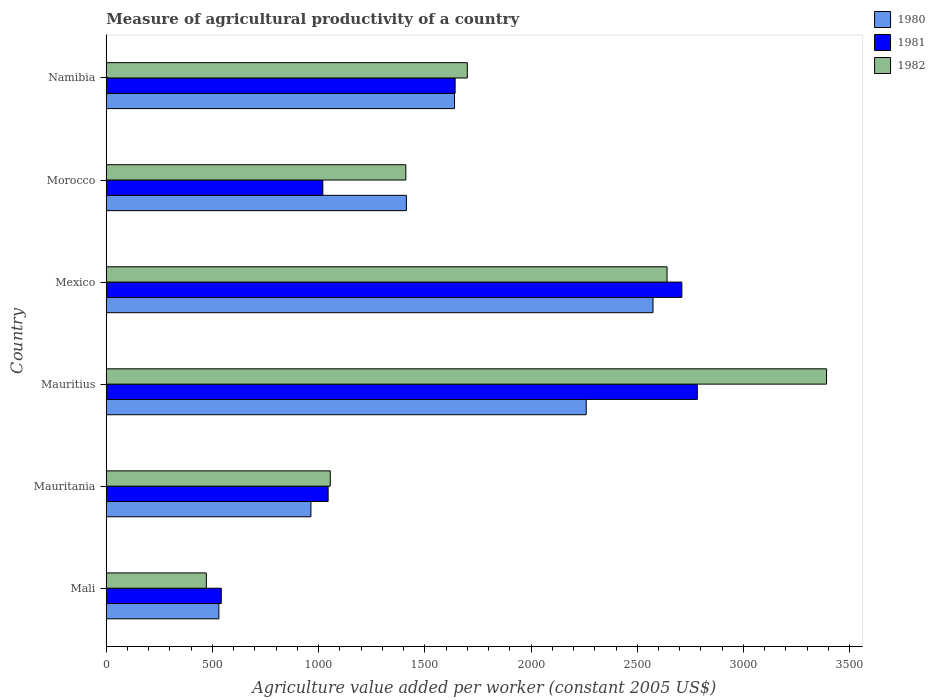How many groups of bars are there?
Keep it short and to the point. 6. What is the label of the 4th group of bars from the top?
Your answer should be very brief. Mauritius. What is the measure of agricultural productivity in 1981 in Morocco?
Keep it short and to the point. 1019.64. Across all countries, what is the maximum measure of agricultural productivity in 1981?
Keep it short and to the point. 2783.08. Across all countries, what is the minimum measure of agricultural productivity in 1981?
Your response must be concise. 541.6. In which country was the measure of agricultural productivity in 1982 maximum?
Your answer should be compact. Mauritius. In which country was the measure of agricultural productivity in 1980 minimum?
Provide a succinct answer. Mali. What is the total measure of agricultural productivity in 1981 in the graph?
Make the answer very short. 9741.52. What is the difference between the measure of agricultural productivity in 1982 in Mali and that in Mexico?
Your response must be concise. -2168.99. What is the difference between the measure of agricultural productivity in 1980 in Namibia and the measure of agricultural productivity in 1982 in Mexico?
Provide a succinct answer. -1000.57. What is the average measure of agricultural productivity in 1981 per country?
Your answer should be very brief. 1623.59. What is the difference between the measure of agricultural productivity in 1981 and measure of agricultural productivity in 1980 in Morocco?
Give a very brief answer. -393.45. What is the ratio of the measure of agricultural productivity in 1980 in Mauritius to that in Morocco?
Offer a very short reply. 1.6. What is the difference between the highest and the second highest measure of agricultural productivity in 1980?
Your answer should be compact. 314.51. What is the difference between the highest and the lowest measure of agricultural productivity in 1982?
Provide a succinct answer. 2919.89. In how many countries, is the measure of agricultural productivity in 1982 greater than the average measure of agricultural productivity in 1982 taken over all countries?
Make the answer very short. 2. Is it the case that in every country, the sum of the measure of agricultural productivity in 1982 and measure of agricultural productivity in 1980 is greater than the measure of agricultural productivity in 1981?
Provide a short and direct response. Yes. How many bars are there?
Ensure brevity in your answer.  18. How many countries are there in the graph?
Your answer should be compact. 6. What is the difference between two consecutive major ticks on the X-axis?
Offer a terse response. 500. Are the values on the major ticks of X-axis written in scientific E-notation?
Ensure brevity in your answer.  No. Does the graph contain any zero values?
Provide a short and direct response. No. Does the graph contain grids?
Offer a terse response. No. How are the legend labels stacked?
Ensure brevity in your answer.  Vertical. What is the title of the graph?
Your response must be concise. Measure of agricultural productivity of a country. Does "2008" appear as one of the legend labels in the graph?
Keep it short and to the point. No. What is the label or title of the X-axis?
Ensure brevity in your answer.  Agriculture value added per worker (constant 2005 US$). What is the label or title of the Y-axis?
Offer a very short reply. Country. What is the Agriculture value added per worker (constant 2005 US$) in 1980 in Mali?
Give a very brief answer. 530.29. What is the Agriculture value added per worker (constant 2005 US$) of 1981 in Mali?
Your response must be concise. 541.6. What is the Agriculture value added per worker (constant 2005 US$) in 1982 in Mali?
Offer a terse response. 471.28. What is the Agriculture value added per worker (constant 2005 US$) in 1980 in Mauritania?
Your answer should be very brief. 963.64. What is the Agriculture value added per worker (constant 2005 US$) in 1981 in Mauritania?
Offer a very short reply. 1044.71. What is the Agriculture value added per worker (constant 2005 US$) in 1982 in Mauritania?
Make the answer very short. 1054.73. What is the Agriculture value added per worker (constant 2005 US$) of 1980 in Mauritius?
Offer a terse response. 2259.73. What is the Agriculture value added per worker (constant 2005 US$) in 1981 in Mauritius?
Provide a short and direct response. 2783.08. What is the Agriculture value added per worker (constant 2005 US$) in 1982 in Mauritius?
Your answer should be very brief. 3391.17. What is the Agriculture value added per worker (constant 2005 US$) in 1980 in Mexico?
Your answer should be compact. 2574.24. What is the Agriculture value added per worker (constant 2005 US$) in 1981 in Mexico?
Provide a short and direct response. 2709.94. What is the Agriculture value added per worker (constant 2005 US$) in 1982 in Mexico?
Ensure brevity in your answer.  2640.27. What is the Agriculture value added per worker (constant 2005 US$) in 1980 in Morocco?
Provide a short and direct response. 1413.09. What is the Agriculture value added per worker (constant 2005 US$) of 1981 in Morocco?
Offer a very short reply. 1019.64. What is the Agriculture value added per worker (constant 2005 US$) in 1982 in Morocco?
Keep it short and to the point. 1410.49. What is the Agriculture value added per worker (constant 2005 US$) in 1980 in Namibia?
Provide a succinct answer. 1639.69. What is the Agriculture value added per worker (constant 2005 US$) in 1981 in Namibia?
Your answer should be compact. 1642.55. What is the Agriculture value added per worker (constant 2005 US$) in 1982 in Namibia?
Make the answer very short. 1699.99. Across all countries, what is the maximum Agriculture value added per worker (constant 2005 US$) of 1980?
Your response must be concise. 2574.24. Across all countries, what is the maximum Agriculture value added per worker (constant 2005 US$) of 1981?
Your answer should be very brief. 2783.08. Across all countries, what is the maximum Agriculture value added per worker (constant 2005 US$) of 1982?
Keep it short and to the point. 3391.17. Across all countries, what is the minimum Agriculture value added per worker (constant 2005 US$) in 1980?
Provide a short and direct response. 530.29. Across all countries, what is the minimum Agriculture value added per worker (constant 2005 US$) in 1981?
Keep it short and to the point. 541.6. Across all countries, what is the minimum Agriculture value added per worker (constant 2005 US$) in 1982?
Give a very brief answer. 471.28. What is the total Agriculture value added per worker (constant 2005 US$) in 1980 in the graph?
Provide a succinct answer. 9380.68. What is the total Agriculture value added per worker (constant 2005 US$) of 1981 in the graph?
Give a very brief answer. 9741.52. What is the total Agriculture value added per worker (constant 2005 US$) of 1982 in the graph?
Give a very brief answer. 1.07e+04. What is the difference between the Agriculture value added per worker (constant 2005 US$) of 1980 in Mali and that in Mauritania?
Your answer should be compact. -433.35. What is the difference between the Agriculture value added per worker (constant 2005 US$) in 1981 in Mali and that in Mauritania?
Your answer should be compact. -503.1. What is the difference between the Agriculture value added per worker (constant 2005 US$) in 1982 in Mali and that in Mauritania?
Offer a terse response. -583.45. What is the difference between the Agriculture value added per worker (constant 2005 US$) in 1980 in Mali and that in Mauritius?
Keep it short and to the point. -1729.44. What is the difference between the Agriculture value added per worker (constant 2005 US$) of 1981 in Mali and that in Mauritius?
Provide a short and direct response. -2241.48. What is the difference between the Agriculture value added per worker (constant 2005 US$) in 1982 in Mali and that in Mauritius?
Make the answer very short. -2919.89. What is the difference between the Agriculture value added per worker (constant 2005 US$) of 1980 in Mali and that in Mexico?
Provide a succinct answer. -2043.95. What is the difference between the Agriculture value added per worker (constant 2005 US$) in 1981 in Mali and that in Mexico?
Offer a terse response. -2168.34. What is the difference between the Agriculture value added per worker (constant 2005 US$) in 1982 in Mali and that in Mexico?
Keep it short and to the point. -2168.99. What is the difference between the Agriculture value added per worker (constant 2005 US$) in 1980 in Mali and that in Morocco?
Ensure brevity in your answer.  -882.8. What is the difference between the Agriculture value added per worker (constant 2005 US$) in 1981 in Mali and that in Morocco?
Make the answer very short. -478.04. What is the difference between the Agriculture value added per worker (constant 2005 US$) of 1982 in Mali and that in Morocco?
Provide a succinct answer. -939.21. What is the difference between the Agriculture value added per worker (constant 2005 US$) in 1980 in Mali and that in Namibia?
Your response must be concise. -1109.4. What is the difference between the Agriculture value added per worker (constant 2005 US$) in 1981 in Mali and that in Namibia?
Provide a succinct answer. -1100.95. What is the difference between the Agriculture value added per worker (constant 2005 US$) of 1982 in Mali and that in Namibia?
Ensure brevity in your answer.  -1228.71. What is the difference between the Agriculture value added per worker (constant 2005 US$) of 1980 in Mauritania and that in Mauritius?
Make the answer very short. -1296.09. What is the difference between the Agriculture value added per worker (constant 2005 US$) of 1981 in Mauritania and that in Mauritius?
Your answer should be very brief. -1738.38. What is the difference between the Agriculture value added per worker (constant 2005 US$) of 1982 in Mauritania and that in Mauritius?
Your answer should be compact. -2336.44. What is the difference between the Agriculture value added per worker (constant 2005 US$) in 1980 in Mauritania and that in Mexico?
Give a very brief answer. -1610.59. What is the difference between the Agriculture value added per worker (constant 2005 US$) in 1981 in Mauritania and that in Mexico?
Provide a short and direct response. -1665.24. What is the difference between the Agriculture value added per worker (constant 2005 US$) of 1982 in Mauritania and that in Mexico?
Provide a short and direct response. -1585.54. What is the difference between the Agriculture value added per worker (constant 2005 US$) in 1980 in Mauritania and that in Morocco?
Provide a succinct answer. -449.45. What is the difference between the Agriculture value added per worker (constant 2005 US$) in 1981 in Mauritania and that in Morocco?
Your answer should be very brief. 25.06. What is the difference between the Agriculture value added per worker (constant 2005 US$) of 1982 in Mauritania and that in Morocco?
Keep it short and to the point. -355.76. What is the difference between the Agriculture value added per worker (constant 2005 US$) in 1980 in Mauritania and that in Namibia?
Your answer should be very brief. -676.05. What is the difference between the Agriculture value added per worker (constant 2005 US$) of 1981 in Mauritania and that in Namibia?
Make the answer very short. -597.85. What is the difference between the Agriculture value added per worker (constant 2005 US$) of 1982 in Mauritania and that in Namibia?
Keep it short and to the point. -645.26. What is the difference between the Agriculture value added per worker (constant 2005 US$) of 1980 in Mauritius and that in Mexico?
Provide a succinct answer. -314.51. What is the difference between the Agriculture value added per worker (constant 2005 US$) in 1981 in Mauritius and that in Mexico?
Offer a terse response. 73.14. What is the difference between the Agriculture value added per worker (constant 2005 US$) of 1982 in Mauritius and that in Mexico?
Offer a terse response. 750.9. What is the difference between the Agriculture value added per worker (constant 2005 US$) of 1980 in Mauritius and that in Morocco?
Your answer should be compact. 846.64. What is the difference between the Agriculture value added per worker (constant 2005 US$) in 1981 in Mauritius and that in Morocco?
Make the answer very short. 1763.44. What is the difference between the Agriculture value added per worker (constant 2005 US$) of 1982 in Mauritius and that in Morocco?
Offer a very short reply. 1980.68. What is the difference between the Agriculture value added per worker (constant 2005 US$) of 1980 in Mauritius and that in Namibia?
Ensure brevity in your answer.  620.04. What is the difference between the Agriculture value added per worker (constant 2005 US$) in 1981 in Mauritius and that in Namibia?
Ensure brevity in your answer.  1140.53. What is the difference between the Agriculture value added per worker (constant 2005 US$) in 1982 in Mauritius and that in Namibia?
Provide a short and direct response. 1691.18. What is the difference between the Agriculture value added per worker (constant 2005 US$) in 1980 in Mexico and that in Morocco?
Your answer should be very brief. 1161.14. What is the difference between the Agriculture value added per worker (constant 2005 US$) in 1981 in Mexico and that in Morocco?
Your answer should be compact. 1690.3. What is the difference between the Agriculture value added per worker (constant 2005 US$) of 1982 in Mexico and that in Morocco?
Ensure brevity in your answer.  1229.78. What is the difference between the Agriculture value added per worker (constant 2005 US$) of 1980 in Mexico and that in Namibia?
Provide a succinct answer. 934.54. What is the difference between the Agriculture value added per worker (constant 2005 US$) in 1981 in Mexico and that in Namibia?
Your answer should be compact. 1067.39. What is the difference between the Agriculture value added per worker (constant 2005 US$) in 1982 in Mexico and that in Namibia?
Offer a terse response. 940.28. What is the difference between the Agriculture value added per worker (constant 2005 US$) of 1980 in Morocco and that in Namibia?
Your response must be concise. -226.6. What is the difference between the Agriculture value added per worker (constant 2005 US$) of 1981 in Morocco and that in Namibia?
Ensure brevity in your answer.  -622.91. What is the difference between the Agriculture value added per worker (constant 2005 US$) in 1982 in Morocco and that in Namibia?
Provide a succinct answer. -289.5. What is the difference between the Agriculture value added per worker (constant 2005 US$) of 1980 in Mali and the Agriculture value added per worker (constant 2005 US$) of 1981 in Mauritania?
Offer a terse response. -514.42. What is the difference between the Agriculture value added per worker (constant 2005 US$) of 1980 in Mali and the Agriculture value added per worker (constant 2005 US$) of 1982 in Mauritania?
Provide a succinct answer. -524.44. What is the difference between the Agriculture value added per worker (constant 2005 US$) in 1981 in Mali and the Agriculture value added per worker (constant 2005 US$) in 1982 in Mauritania?
Your answer should be compact. -513.12. What is the difference between the Agriculture value added per worker (constant 2005 US$) in 1980 in Mali and the Agriculture value added per worker (constant 2005 US$) in 1981 in Mauritius?
Offer a very short reply. -2252.79. What is the difference between the Agriculture value added per worker (constant 2005 US$) of 1980 in Mali and the Agriculture value added per worker (constant 2005 US$) of 1982 in Mauritius?
Your answer should be compact. -2860.88. What is the difference between the Agriculture value added per worker (constant 2005 US$) in 1981 in Mali and the Agriculture value added per worker (constant 2005 US$) in 1982 in Mauritius?
Offer a terse response. -2849.57. What is the difference between the Agriculture value added per worker (constant 2005 US$) of 1980 in Mali and the Agriculture value added per worker (constant 2005 US$) of 1981 in Mexico?
Your answer should be very brief. -2179.65. What is the difference between the Agriculture value added per worker (constant 2005 US$) in 1980 in Mali and the Agriculture value added per worker (constant 2005 US$) in 1982 in Mexico?
Provide a succinct answer. -2109.98. What is the difference between the Agriculture value added per worker (constant 2005 US$) in 1981 in Mali and the Agriculture value added per worker (constant 2005 US$) in 1982 in Mexico?
Provide a succinct answer. -2098.66. What is the difference between the Agriculture value added per worker (constant 2005 US$) in 1980 in Mali and the Agriculture value added per worker (constant 2005 US$) in 1981 in Morocco?
Provide a short and direct response. -489.35. What is the difference between the Agriculture value added per worker (constant 2005 US$) in 1980 in Mali and the Agriculture value added per worker (constant 2005 US$) in 1982 in Morocco?
Provide a short and direct response. -880.2. What is the difference between the Agriculture value added per worker (constant 2005 US$) of 1981 in Mali and the Agriculture value added per worker (constant 2005 US$) of 1982 in Morocco?
Offer a terse response. -868.89. What is the difference between the Agriculture value added per worker (constant 2005 US$) of 1980 in Mali and the Agriculture value added per worker (constant 2005 US$) of 1981 in Namibia?
Your answer should be compact. -1112.26. What is the difference between the Agriculture value added per worker (constant 2005 US$) of 1980 in Mali and the Agriculture value added per worker (constant 2005 US$) of 1982 in Namibia?
Ensure brevity in your answer.  -1169.7. What is the difference between the Agriculture value added per worker (constant 2005 US$) of 1981 in Mali and the Agriculture value added per worker (constant 2005 US$) of 1982 in Namibia?
Provide a short and direct response. -1158.38. What is the difference between the Agriculture value added per worker (constant 2005 US$) of 1980 in Mauritania and the Agriculture value added per worker (constant 2005 US$) of 1981 in Mauritius?
Your answer should be compact. -1819.44. What is the difference between the Agriculture value added per worker (constant 2005 US$) of 1980 in Mauritania and the Agriculture value added per worker (constant 2005 US$) of 1982 in Mauritius?
Your answer should be very brief. -2427.53. What is the difference between the Agriculture value added per worker (constant 2005 US$) of 1981 in Mauritania and the Agriculture value added per worker (constant 2005 US$) of 1982 in Mauritius?
Keep it short and to the point. -2346.46. What is the difference between the Agriculture value added per worker (constant 2005 US$) of 1980 in Mauritania and the Agriculture value added per worker (constant 2005 US$) of 1981 in Mexico?
Provide a succinct answer. -1746.3. What is the difference between the Agriculture value added per worker (constant 2005 US$) of 1980 in Mauritania and the Agriculture value added per worker (constant 2005 US$) of 1982 in Mexico?
Keep it short and to the point. -1676.62. What is the difference between the Agriculture value added per worker (constant 2005 US$) of 1981 in Mauritania and the Agriculture value added per worker (constant 2005 US$) of 1982 in Mexico?
Offer a very short reply. -1595.56. What is the difference between the Agriculture value added per worker (constant 2005 US$) in 1980 in Mauritania and the Agriculture value added per worker (constant 2005 US$) in 1981 in Morocco?
Your answer should be very brief. -56. What is the difference between the Agriculture value added per worker (constant 2005 US$) in 1980 in Mauritania and the Agriculture value added per worker (constant 2005 US$) in 1982 in Morocco?
Offer a very short reply. -446.85. What is the difference between the Agriculture value added per worker (constant 2005 US$) of 1981 in Mauritania and the Agriculture value added per worker (constant 2005 US$) of 1982 in Morocco?
Your response must be concise. -365.78. What is the difference between the Agriculture value added per worker (constant 2005 US$) in 1980 in Mauritania and the Agriculture value added per worker (constant 2005 US$) in 1981 in Namibia?
Offer a terse response. -678.91. What is the difference between the Agriculture value added per worker (constant 2005 US$) in 1980 in Mauritania and the Agriculture value added per worker (constant 2005 US$) in 1982 in Namibia?
Offer a terse response. -736.35. What is the difference between the Agriculture value added per worker (constant 2005 US$) of 1981 in Mauritania and the Agriculture value added per worker (constant 2005 US$) of 1982 in Namibia?
Your response must be concise. -655.28. What is the difference between the Agriculture value added per worker (constant 2005 US$) in 1980 in Mauritius and the Agriculture value added per worker (constant 2005 US$) in 1981 in Mexico?
Keep it short and to the point. -450.21. What is the difference between the Agriculture value added per worker (constant 2005 US$) in 1980 in Mauritius and the Agriculture value added per worker (constant 2005 US$) in 1982 in Mexico?
Provide a succinct answer. -380.54. What is the difference between the Agriculture value added per worker (constant 2005 US$) of 1981 in Mauritius and the Agriculture value added per worker (constant 2005 US$) of 1982 in Mexico?
Keep it short and to the point. 142.82. What is the difference between the Agriculture value added per worker (constant 2005 US$) of 1980 in Mauritius and the Agriculture value added per worker (constant 2005 US$) of 1981 in Morocco?
Make the answer very short. 1240.09. What is the difference between the Agriculture value added per worker (constant 2005 US$) of 1980 in Mauritius and the Agriculture value added per worker (constant 2005 US$) of 1982 in Morocco?
Your response must be concise. 849.24. What is the difference between the Agriculture value added per worker (constant 2005 US$) of 1981 in Mauritius and the Agriculture value added per worker (constant 2005 US$) of 1982 in Morocco?
Your response must be concise. 1372.59. What is the difference between the Agriculture value added per worker (constant 2005 US$) in 1980 in Mauritius and the Agriculture value added per worker (constant 2005 US$) in 1981 in Namibia?
Make the answer very short. 617.18. What is the difference between the Agriculture value added per worker (constant 2005 US$) of 1980 in Mauritius and the Agriculture value added per worker (constant 2005 US$) of 1982 in Namibia?
Your answer should be compact. 559.74. What is the difference between the Agriculture value added per worker (constant 2005 US$) in 1981 in Mauritius and the Agriculture value added per worker (constant 2005 US$) in 1982 in Namibia?
Provide a succinct answer. 1083.1. What is the difference between the Agriculture value added per worker (constant 2005 US$) in 1980 in Mexico and the Agriculture value added per worker (constant 2005 US$) in 1981 in Morocco?
Your answer should be very brief. 1554.6. What is the difference between the Agriculture value added per worker (constant 2005 US$) of 1980 in Mexico and the Agriculture value added per worker (constant 2005 US$) of 1982 in Morocco?
Offer a terse response. 1163.75. What is the difference between the Agriculture value added per worker (constant 2005 US$) in 1981 in Mexico and the Agriculture value added per worker (constant 2005 US$) in 1982 in Morocco?
Ensure brevity in your answer.  1299.45. What is the difference between the Agriculture value added per worker (constant 2005 US$) of 1980 in Mexico and the Agriculture value added per worker (constant 2005 US$) of 1981 in Namibia?
Your response must be concise. 931.68. What is the difference between the Agriculture value added per worker (constant 2005 US$) in 1980 in Mexico and the Agriculture value added per worker (constant 2005 US$) in 1982 in Namibia?
Your answer should be very brief. 874.25. What is the difference between the Agriculture value added per worker (constant 2005 US$) in 1981 in Mexico and the Agriculture value added per worker (constant 2005 US$) in 1982 in Namibia?
Offer a terse response. 1009.95. What is the difference between the Agriculture value added per worker (constant 2005 US$) of 1980 in Morocco and the Agriculture value added per worker (constant 2005 US$) of 1981 in Namibia?
Keep it short and to the point. -229.46. What is the difference between the Agriculture value added per worker (constant 2005 US$) in 1980 in Morocco and the Agriculture value added per worker (constant 2005 US$) in 1982 in Namibia?
Offer a terse response. -286.9. What is the difference between the Agriculture value added per worker (constant 2005 US$) in 1981 in Morocco and the Agriculture value added per worker (constant 2005 US$) in 1982 in Namibia?
Make the answer very short. -680.35. What is the average Agriculture value added per worker (constant 2005 US$) of 1980 per country?
Offer a terse response. 1563.45. What is the average Agriculture value added per worker (constant 2005 US$) in 1981 per country?
Your answer should be very brief. 1623.59. What is the average Agriculture value added per worker (constant 2005 US$) in 1982 per country?
Your answer should be compact. 1777.99. What is the difference between the Agriculture value added per worker (constant 2005 US$) in 1980 and Agriculture value added per worker (constant 2005 US$) in 1981 in Mali?
Offer a very short reply. -11.31. What is the difference between the Agriculture value added per worker (constant 2005 US$) in 1980 and Agriculture value added per worker (constant 2005 US$) in 1982 in Mali?
Your answer should be very brief. 59.01. What is the difference between the Agriculture value added per worker (constant 2005 US$) of 1981 and Agriculture value added per worker (constant 2005 US$) of 1982 in Mali?
Keep it short and to the point. 70.33. What is the difference between the Agriculture value added per worker (constant 2005 US$) of 1980 and Agriculture value added per worker (constant 2005 US$) of 1981 in Mauritania?
Give a very brief answer. -81.06. What is the difference between the Agriculture value added per worker (constant 2005 US$) in 1980 and Agriculture value added per worker (constant 2005 US$) in 1982 in Mauritania?
Make the answer very short. -91.08. What is the difference between the Agriculture value added per worker (constant 2005 US$) of 1981 and Agriculture value added per worker (constant 2005 US$) of 1982 in Mauritania?
Provide a short and direct response. -10.02. What is the difference between the Agriculture value added per worker (constant 2005 US$) in 1980 and Agriculture value added per worker (constant 2005 US$) in 1981 in Mauritius?
Make the answer very short. -523.35. What is the difference between the Agriculture value added per worker (constant 2005 US$) of 1980 and Agriculture value added per worker (constant 2005 US$) of 1982 in Mauritius?
Your response must be concise. -1131.44. What is the difference between the Agriculture value added per worker (constant 2005 US$) of 1981 and Agriculture value added per worker (constant 2005 US$) of 1982 in Mauritius?
Offer a very short reply. -608.09. What is the difference between the Agriculture value added per worker (constant 2005 US$) of 1980 and Agriculture value added per worker (constant 2005 US$) of 1981 in Mexico?
Offer a terse response. -135.71. What is the difference between the Agriculture value added per worker (constant 2005 US$) of 1980 and Agriculture value added per worker (constant 2005 US$) of 1982 in Mexico?
Your answer should be very brief. -66.03. What is the difference between the Agriculture value added per worker (constant 2005 US$) in 1981 and Agriculture value added per worker (constant 2005 US$) in 1982 in Mexico?
Make the answer very short. 69.68. What is the difference between the Agriculture value added per worker (constant 2005 US$) in 1980 and Agriculture value added per worker (constant 2005 US$) in 1981 in Morocco?
Provide a succinct answer. 393.45. What is the difference between the Agriculture value added per worker (constant 2005 US$) of 1980 and Agriculture value added per worker (constant 2005 US$) of 1982 in Morocco?
Give a very brief answer. 2.6. What is the difference between the Agriculture value added per worker (constant 2005 US$) of 1981 and Agriculture value added per worker (constant 2005 US$) of 1982 in Morocco?
Provide a succinct answer. -390.85. What is the difference between the Agriculture value added per worker (constant 2005 US$) of 1980 and Agriculture value added per worker (constant 2005 US$) of 1981 in Namibia?
Your answer should be very brief. -2.86. What is the difference between the Agriculture value added per worker (constant 2005 US$) of 1980 and Agriculture value added per worker (constant 2005 US$) of 1982 in Namibia?
Keep it short and to the point. -60.3. What is the difference between the Agriculture value added per worker (constant 2005 US$) of 1981 and Agriculture value added per worker (constant 2005 US$) of 1982 in Namibia?
Provide a short and direct response. -57.44. What is the ratio of the Agriculture value added per worker (constant 2005 US$) in 1980 in Mali to that in Mauritania?
Ensure brevity in your answer.  0.55. What is the ratio of the Agriculture value added per worker (constant 2005 US$) of 1981 in Mali to that in Mauritania?
Keep it short and to the point. 0.52. What is the ratio of the Agriculture value added per worker (constant 2005 US$) of 1982 in Mali to that in Mauritania?
Provide a short and direct response. 0.45. What is the ratio of the Agriculture value added per worker (constant 2005 US$) of 1980 in Mali to that in Mauritius?
Give a very brief answer. 0.23. What is the ratio of the Agriculture value added per worker (constant 2005 US$) in 1981 in Mali to that in Mauritius?
Make the answer very short. 0.19. What is the ratio of the Agriculture value added per worker (constant 2005 US$) of 1982 in Mali to that in Mauritius?
Your answer should be compact. 0.14. What is the ratio of the Agriculture value added per worker (constant 2005 US$) of 1980 in Mali to that in Mexico?
Provide a succinct answer. 0.21. What is the ratio of the Agriculture value added per worker (constant 2005 US$) in 1981 in Mali to that in Mexico?
Your answer should be compact. 0.2. What is the ratio of the Agriculture value added per worker (constant 2005 US$) in 1982 in Mali to that in Mexico?
Provide a short and direct response. 0.18. What is the ratio of the Agriculture value added per worker (constant 2005 US$) of 1980 in Mali to that in Morocco?
Your answer should be compact. 0.38. What is the ratio of the Agriculture value added per worker (constant 2005 US$) in 1981 in Mali to that in Morocco?
Make the answer very short. 0.53. What is the ratio of the Agriculture value added per worker (constant 2005 US$) in 1982 in Mali to that in Morocco?
Keep it short and to the point. 0.33. What is the ratio of the Agriculture value added per worker (constant 2005 US$) of 1980 in Mali to that in Namibia?
Your answer should be compact. 0.32. What is the ratio of the Agriculture value added per worker (constant 2005 US$) in 1981 in Mali to that in Namibia?
Give a very brief answer. 0.33. What is the ratio of the Agriculture value added per worker (constant 2005 US$) of 1982 in Mali to that in Namibia?
Provide a succinct answer. 0.28. What is the ratio of the Agriculture value added per worker (constant 2005 US$) in 1980 in Mauritania to that in Mauritius?
Ensure brevity in your answer.  0.43. What is the ratio of the Agriculture value added per worker (constant 2005 US$) of 1981 in Mauritania to that in Mauritius?
Offer a very short reply. 0.38. What is the ratio of the Agriculture value added per worker (constant 2005 US$) in 1982 in Mauritania to that in Mauritius?
Provide a short and direct response. 0.31. What is the ratio of the Agriculture value added per worker (constant 2005 US$) of 1980 in Mauritania to that in Mexico?
Ensure brevity in your answer.  0.37. What is the ratio of the Agriculture value added per worker (constant 2005 US$) in 1981 in Mauritania to that in Mexico?
Keep it short and to the point. 0.39. What is the ratio of the Agriculture value added per worker (constant 2005 US$) of 1982 in Mauritania to that in Mexico?
Your response must be concise. 0.4. What is the ratio of the Agriculture value added per worker (constant 2005 US$) of 1980 in Mauritania to that in Morocco?
Your answer should be very brief. 0.68. What is the ratio of the Agriculture value added per worker (constant 2005 US$) of 1981 in Mauritania to that in Morocco?
Give a very brief answer. 1.02. What is the ratio of the Agriculture value added per worker (constant 2005 US$) in 1982 in Mauritania to that in Morocco?
Your response must be concise. 0.75. What is the ratio of the Agriculture value added per worker (constant 2005 US$) in 1980 in Mauritania to that in Namibia?
Your response must be concise. 0.59. What is the ratio of the Agriculture value added per worker (constant 2005 US$) in 1981 in Mauritania to that in Namibia?
Provide a succinct answer. 0.64. What is the ratio of the Agriculture value added per worker (constant 2005 US$) in 1982 in Mauritania to that in Namibia?
Offer a terse response. 0.62. What is the ratio of the Agriculture value added per worker (constant 2005 US$) of 1980 in Mauritius to that in Mexico?
Give a very brief answer. 0.88. What is the ratio of the Agriculture value added per worker (constant 2005 US$) of 1982 in Mauritius to that in Mexico?
Offer a very short reply. 1.28. What is the ratio of the Agriculture value added per worker (constant 2005 US$) of 1980 in Mauritius to that in Morocco?
Keep it short and to the point. 1.6. What is the ratio of the Agriculture value added per worker (constant 2005 US$) of 1981 in Mauritius to that in Morocco?
Provide a succinct answer. 2.73. What is the ratio of the Agriculture value added per worker (constant 2005 US$) of 1982 in Mauritius to that in Morocco?
Your answer should be very brief. 2.4. What is the ratio of the Agriculture value added per worker (constant 2005 US$) in 1980 in Mauritius to that in Namibia?
Offer a terse response. 1.38. What is the ratio of the Agriculture value added per worker (constant 2005 US$) of 1981 in Mauritius to that in Namibia?
Your answer should be very brief. 1.69. What is the ratio of the Agriculture value added per worker (constant 2005 US$) in 1982 in Mauritius to that in Namibia?
Provide a succinct answer. 1.99. What is the ratio of the Agriculture value added per worker (constant 2005 US$) in 1980 in Mexico to that in Morocco?
Give a very brief answer. 1.82. What is the ratio of the Agriculture value added per worker (constant 2005 US$) of 1981 in Mexico to that in Morocco?
Keep it short and to the point. 2.66. What is the ratio of the Agriculture value added per worker (constant 2005 US$) in 1982 in Mexico to that in Morocco?
Offer a very short reply. 1.87. What is the ratio of the Agriculture value added per worker (constant 2005 US$) of 1980 in Mexico to that in Namibia?
Your response must be concise. 1.57. What is the ratio of the Agriculture value added per worker (constant 2005 US$) in 1981 in Mexico to that in Namibia?
Ensure brevity in your answer.  1.65. What is the ratio of the Agriculture value added per worker (constant 2005 US$) of 1982 in Mexico to that in Namibia?
Ensure brevity in your answer.  1.55. What is the ratio of the Agriculture value added per worker (constant 2005 US$) in 1980 in Morocco to that in Namibia?
Keep it short and to the point. 0.86. What is the ratio of the Agriculture value added per worker (constant 2005 US$) in 1981 in Morocco to that in Namibia?
Ensure brevity in your answer.  0.62. What is the ratio of the Agriculture value added per worker (constant 2005 US$) of 1982 in Morocco to that in Namibia?
Offer a terse response. 0.83. What is the difference between the highest and the second highest Agriculture value added per worker (constant 2005 US$) of 1980?
Give a very brief answer. 314.51. What is the difference between the highest and the second highest Agriculture value added per worker (constant 2005 US$) of 1981?
Keep it short and to the point. 73.14. What is the difference between the highest and the second highest Agriculture value added per worker (constant 2005 US$) in 1982?
Offer a terse response. 750.9. What is the difference between the highest and the lowest Agriculture value added per worker (constant 2005 US$) in 1980?
Your answer should be very brief. 2043.95. What is the difference between the highest and the lowest Agriculture value added per worker (constant 2005 US$) of 1981?
Provide a short and direct response. 2241.48. What is the difference between the highest and the lowest Agriculture value added per worker (constant 2005 US$) in 1982?
Keep it short and to the point. 2919.89. 